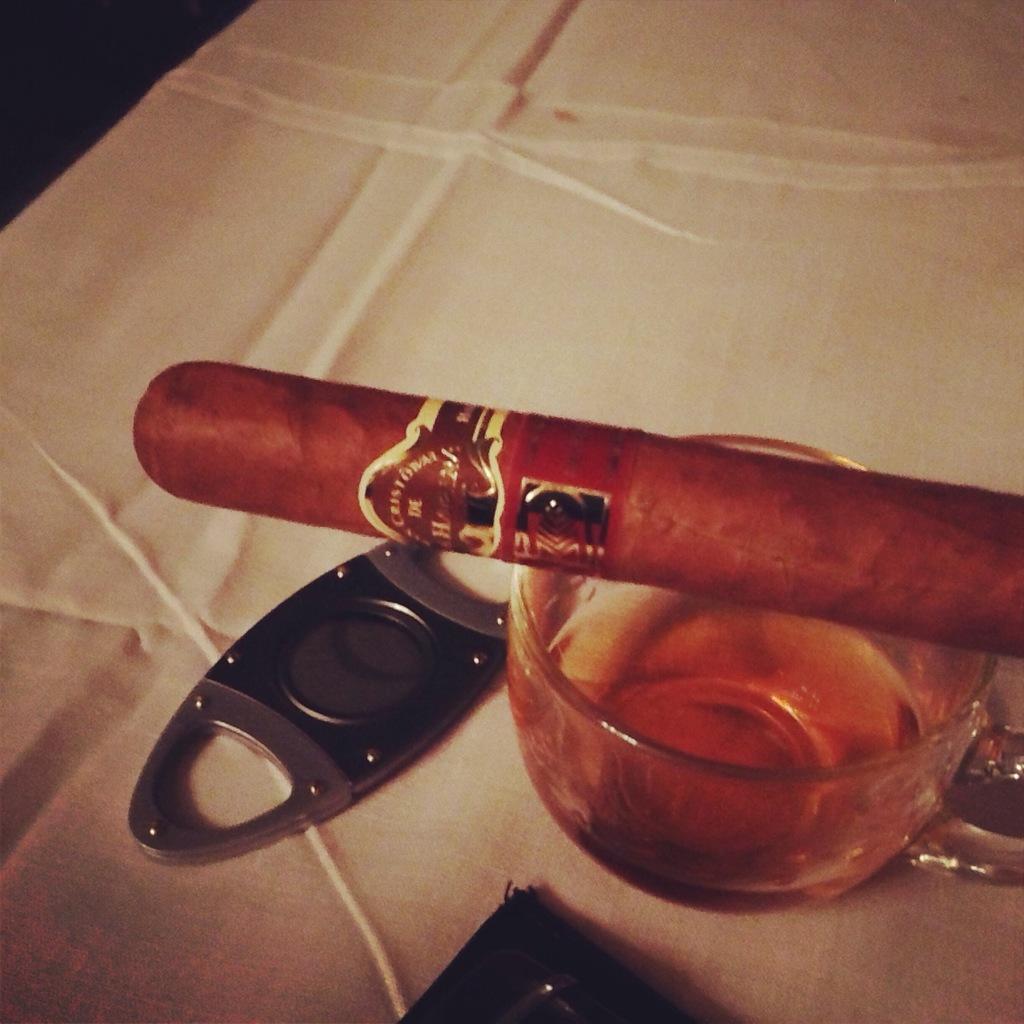How would you summarize this image in a sentence or two? In the center of the image we can see beverage in cup, opener placed on the table. 